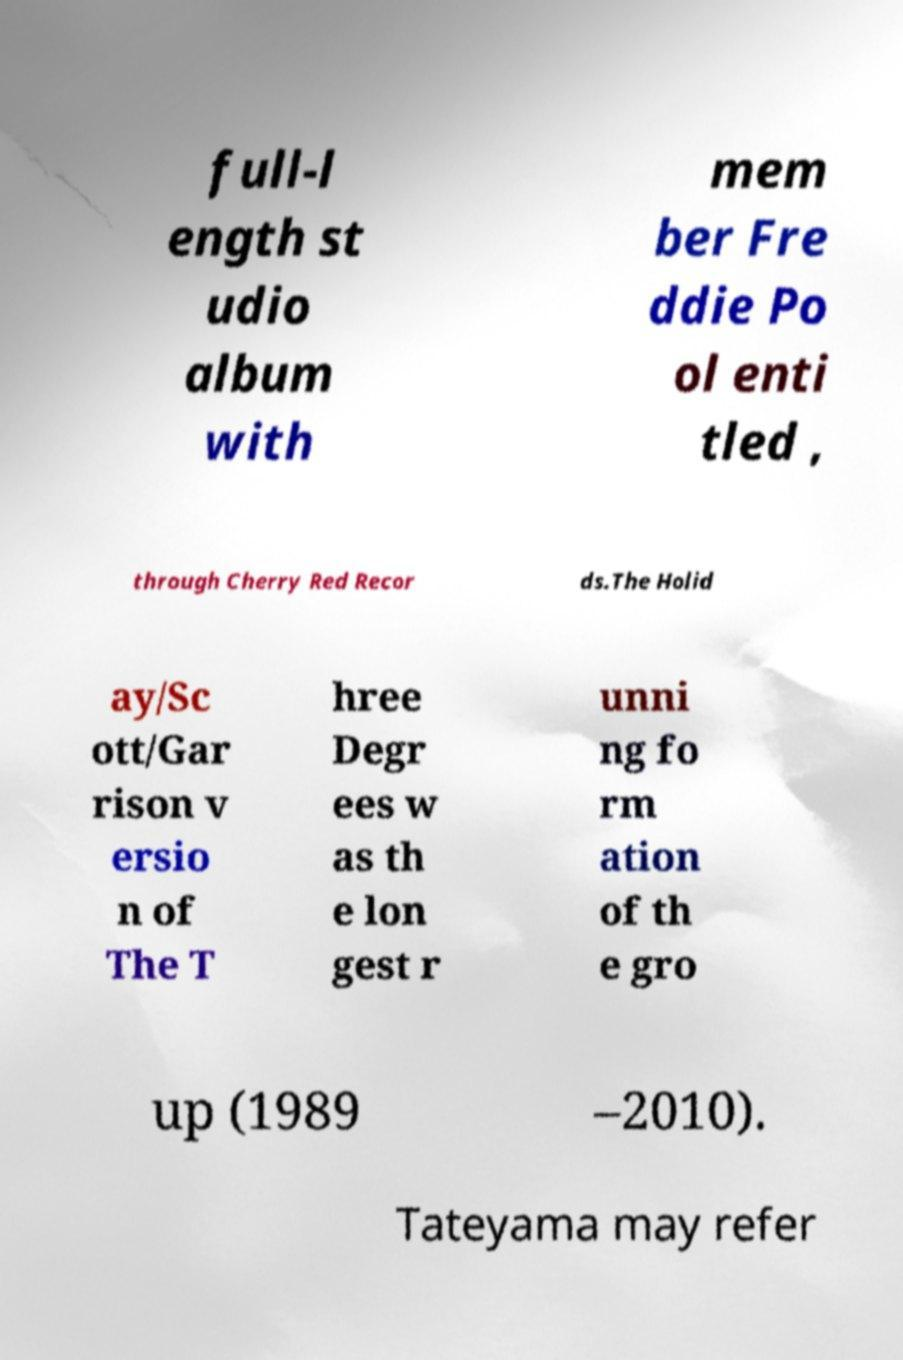There's text embedded in this image that I need extracted. Can you transcribe it verbatim? full-l ength st udio album with mem ber Fre ddie Po ol enti tled , through Cherry Red Recor ds.The Holid ay/Sc ott/Gar rison v ersio n of The T hree Degr ees w as th e lon gest r unni ng fo rm ation of th e gro up (1989 –2010). Tateyama may refer 